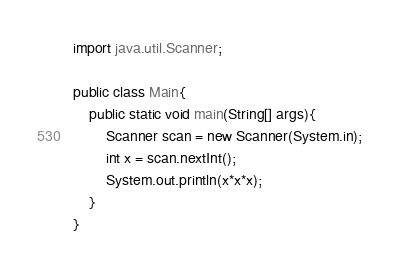Convert code to text. <code><loc_0><loc_0><loc_500><loc_500><_Java_>import java.util.Scanner;

public class Main{
    public static void main(String[] args){
        Scanner scan = new Scanner(System.in);
        int x = scan.nextInt();
        System.out.println(x*x*x);
    }
}
</code> 